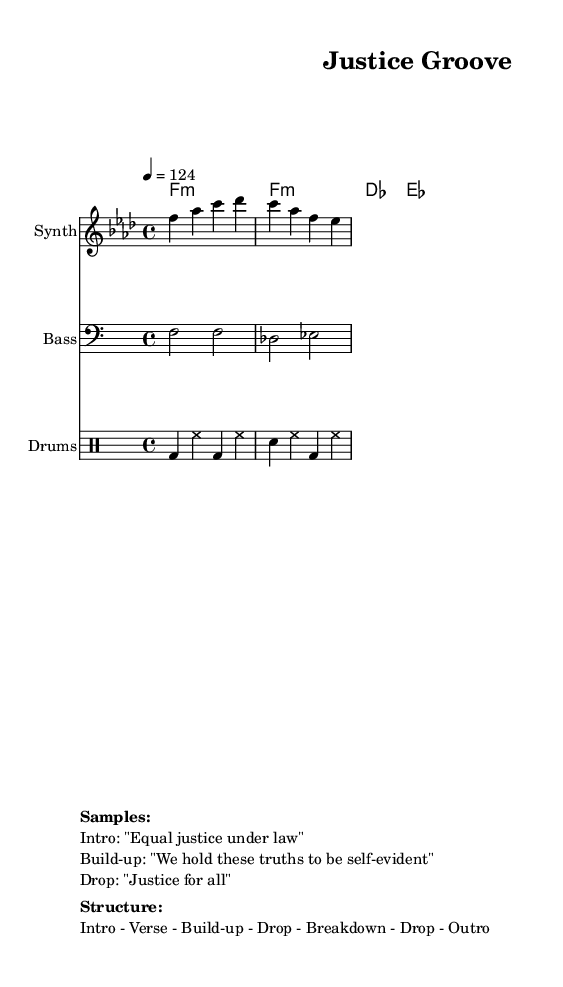What is the key signature of this music? The key signature is indicated by the key signature at the beginning of the score, which shows one flat, corresponding to F minor.
Answer: F minor What is the time signature of this music? The time signature is shown in the beginning of the score, represented as 4/4. This means there are four beats in each measure and the quarter note gets one beat.
Answer: 4/4 What is the tempo marking for this music? The tempo marking is indicated in beats per minute, shown as "4 = 124", meaning 124 beats per minute.
Answer: 124 How many measures does the melody section contain? By analyzing the melody section, there are 2 measures in the example provided for that melody line.
Answer: 2 What are the samples used in this track? The samples are listed in the markup section at the end of the score. The samples mentioned are: "Equal justice under law", "We hold these truths to be self-evident", and "Justice for all".
Answer: Equal justice under law, We hold these truths to be self-evident, Justice for all What is the structure of the track? The structure is detailed in the markup section, which describes the order of sections within the piece: Intro - Verse - Build-up - Drop - Breakdown - Drop - Outro.
Answer: Intro - Verse - Build-up - Drop - Breakdown - Drop - Outro What type of musical genre does this track belong to? This track is labeled as "Deep house" since it follows the characteristics of deep house music, which often includes aspects like complex melodic lines and a laid-back tempo.
Answer: Deep house 